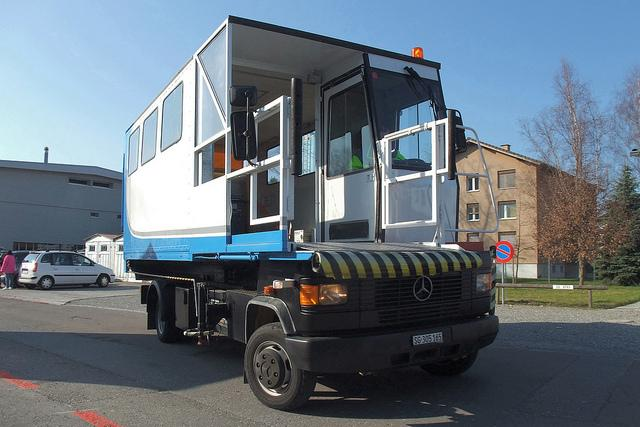What company made this vehicle?

Choices:
A) mercedes
B) toyota
C) audi
D) hyundai mercedes 